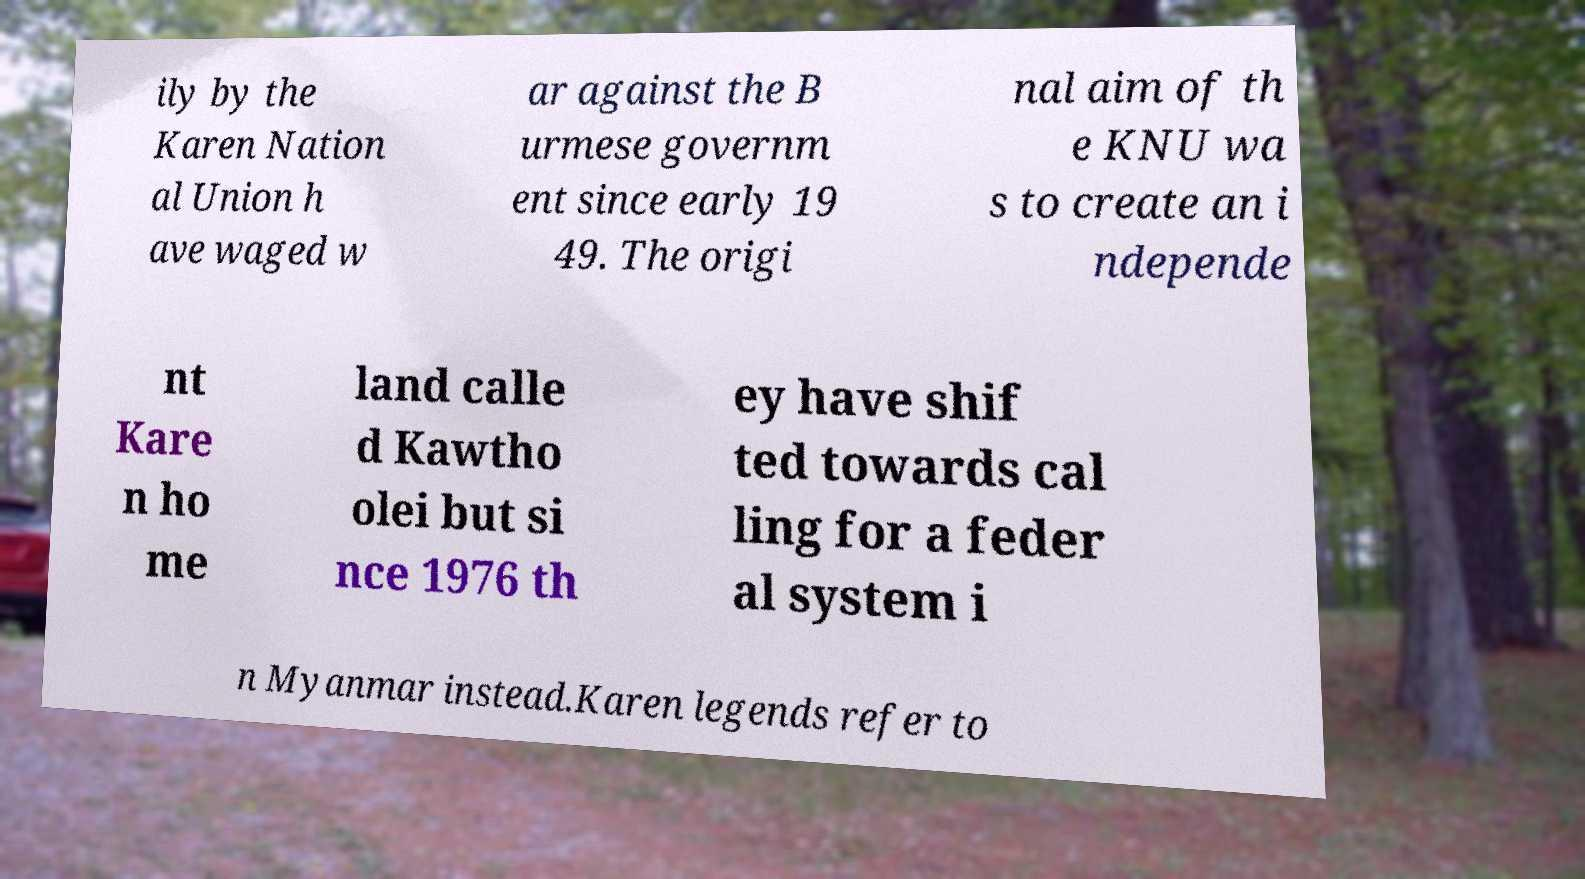I need the written content from this picture converted into text. Can you do that? ily by the Karen Nation al Union h ave waged w ar against the B urmese governm ent since early 19 49. The origi nal aim of th e KNU wa s to create an i ndepende nt Kare n ho me land calle d Kawtho olei but si nce 1976 th ey have shif ted towards cal ling for a feder al system i n Myanmar instead.Karen legends refer to 